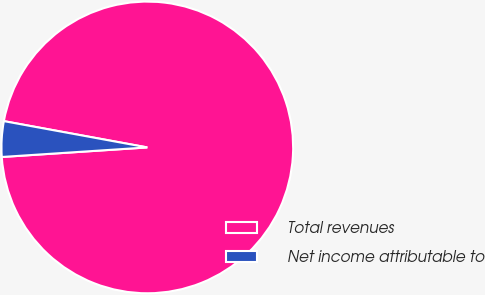Convert chart. <chart><loc_0><loc_0><loc_500><loc_500><pie_chart><fcel>Total revenues<fcel>Net income attributable to<nl><fcel>96.07%<fcel>3.93%<nl></chart> 